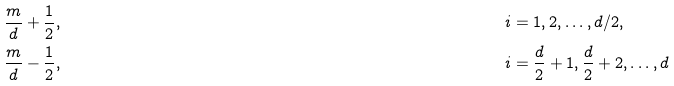<formula> <loc_0><loc_0><loc_500><loc_500>& \frac { m } { d } + \frac { 1 } { 2 } , & i & = 1 , 2 , \dots , d / 2 , \\ & \frac { m } { d } - \frac { 1 } { 2 } , & i & = \frac { d } { 2 } + 1 , \frac { d } { 2 } + 2 , \dots , d</formula> 